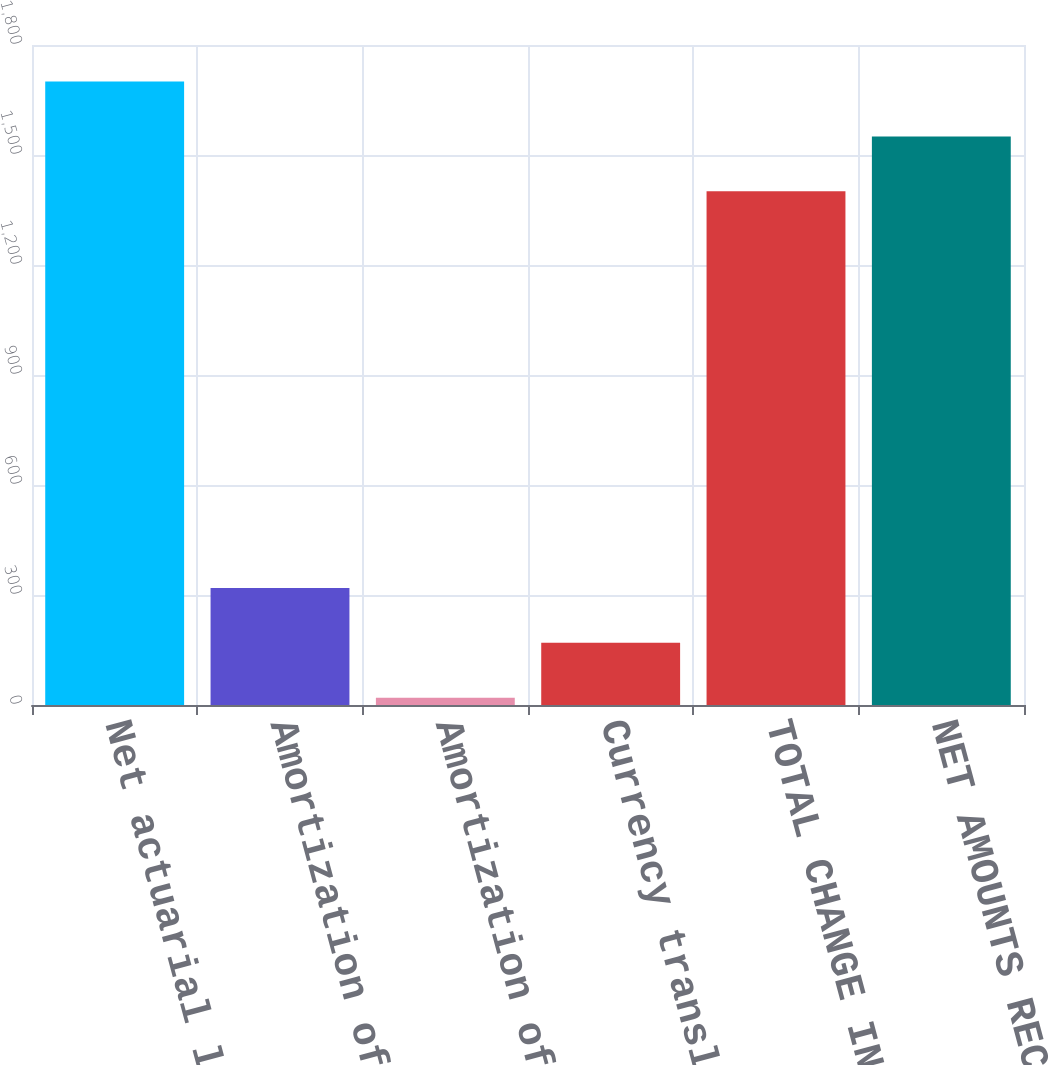Convert chart. <chart><loc_0><loc_0><loc_500><loc_500><bar_chart><fcel>Net actuarial loss /(gain) -<fcel>Amortization of net actuarial<fcel>Amortization of prior service<fcel>Currency translation and other<fcel>TOTAL CHANGE IN AOCI<fcel>NET AMOUNTS RECOGNIZED IN<nl><fcel>1700.2<fcel>319.2<fcel>20<fcel>169.6<fcel>1401<fcel>1550.6<nl></chart> 